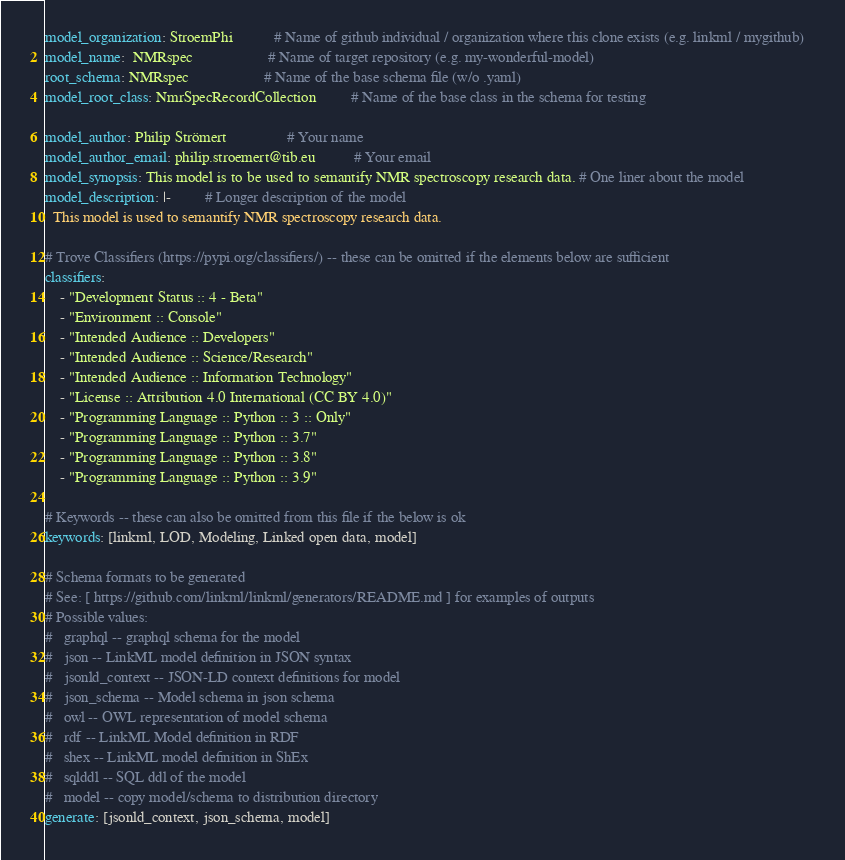Convert code to text. <code><loc_0><loc_0><loc_500><loc_500><_YAML_>model_organization: StroemPhi           # Name of github individual / organization where this clone exists (e.g. linkml / mygithub)   
model_name:  NMRspec                    # Name of target repository (e.g. my-wonderful-model)
root_schema: NMRspec                    # Name of the base schema file (w/o .yaml)
model_root_class: NmrSpecRecordCollection         # Name of the base class in the schema for testing

model_author: Philip Strömert                # Your name
model_author_email: philip.stroemert@tib.eu          # Your email
model_synopsis: This model is to be used to semantify NMR spectroscopy research data. # One liner about the model
model_description: |-         # Longer description of the model
  This model is used to semantify NMR spectroscopy research data.

# Trove Classifiers (https://pypi.org/classifiers/) -- these can be omitted if the elements below are sufficient
classifiers:
    - "Development Status :: 4 - Beta"
    - "Environment :: Console"
    - "Intended Audience :: Developers"
    - "Intended Audience :: Science/Research"
    - "Intended Audience :: Information Technology"
    - "License :: Attribution 4.0 International (CC BY 4.0)"
    - "Programming Language :: Python :: 3 :: Only"
    - "Programming Language :: Python :: 3.7"
    - "Programming Language :: Python :: 3.8"
    - "Programming Language :: Python :: 3.9"

# Keywords -- these can also be omitted from this file if the below is ok
keywords: [linkml, LOD, Modeling, Linked open data, model]

# Schema formats to be generated
# See: [ https://github.com/linkml/linkml/generators/README.md ] for examples of outputs
# Possible values:
#   graphql -- graphql schema for the model
#   json -- LinkML model definition in JSON syntax
#   jsonld_context -- JSON-LD context definitions for model
#   json_schema -- Model schema in json schema
#   owl -- OWL representation of model schema
#   rdf -- LinkML Model definition in RDF
#   shex -- LinkML model definition in ShEx
#   sqlddl -- SQL ddl of the model
#   model -- copy model/schema to distribution directory
generate: [jsonld_context, json_schema, model]

</code> 